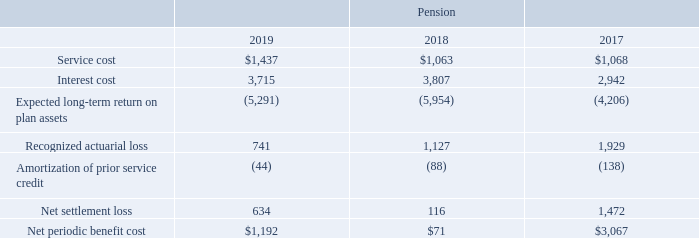Net Periodic Benefit Cost
The following table provides information about the net periodic benefit cost for the plans for fiscal years 2019, 2018 and 2017 (in thousands):
On September 1, 2018, the Company adopted a new accounting standard, which changes the presentation of net periodic benefit cost in the Consolidated Statements of Operation. The Company adopted the standard on a retrospective basis which results in reclassifications for the service cost component of net periodic benefit cost from selling, general and administrative expense to cost of revenue and for the other components from selling, general and administrative expense to other expense. Prior periods have not been reclassified due to immateriality.
Which fiscal years does the table provide information about the net periodic benefit cost for? 2019, 2018, 2017. What was the service cost in 2019?
Answer scale should be: thousand. $1,437. What was the interest cost in 2018?
Answer scale should be: thousand. 3,807. What was the change in interest cost between 2018 and 2019?
Answer scale should be: thousand. 3,715-3,807
Answer: -92. How many years did the recognized actuarial loss exceed $1,000 thousand? 2018##2017
Answer: 2. What was the total percentage change in the Net periodic benefit cost between 2017 and 2019?
Answer scale should be: percent. ($1,192-$3,067)/$3,067
Answer: -61.13. 